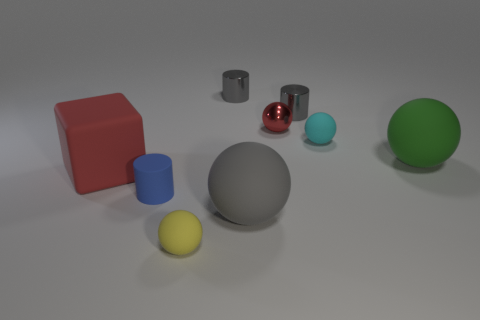Does the shiny ball have the same color as the rubber cube?
Your answer should be very brief. Yes. There is a cube that is the same size as the gray sphere; what is its color?
Your answer should be very brief. Red. How many objects are either large rubber spheres that are in front of the blue rubber cylinder or gray things?
Make the answer very short. 3. What size is the thing that is both to the right of the large cube and on the left side of the tiny yellow object?
Offer a very short reply. Small. What size is the rubber block that is the same color as the small metallic sphere?
Keep it short and to the point. Large. What number of other objects are there of the same size as the cyan object?
Offer a terse response. 5. There is a large rubber ball that is on the left side of the matte ball that is on the right side of the small matte ball that is behind the matte cylinder; what is its color?
Keep it short and to the point. Gray. There is a object that is both behind the matte cube and on the left side of the gray rubber ball; what shape is it?
Keep it short and to the point. Cylinder. How many other objects are there of the same shape as the cyan matte object?
Ensure brevity in your answer.  4. What shape is the red object left of the large ball in front of the big matte ball that is behind the blue object?
Provide a succinct answer. Cube. 